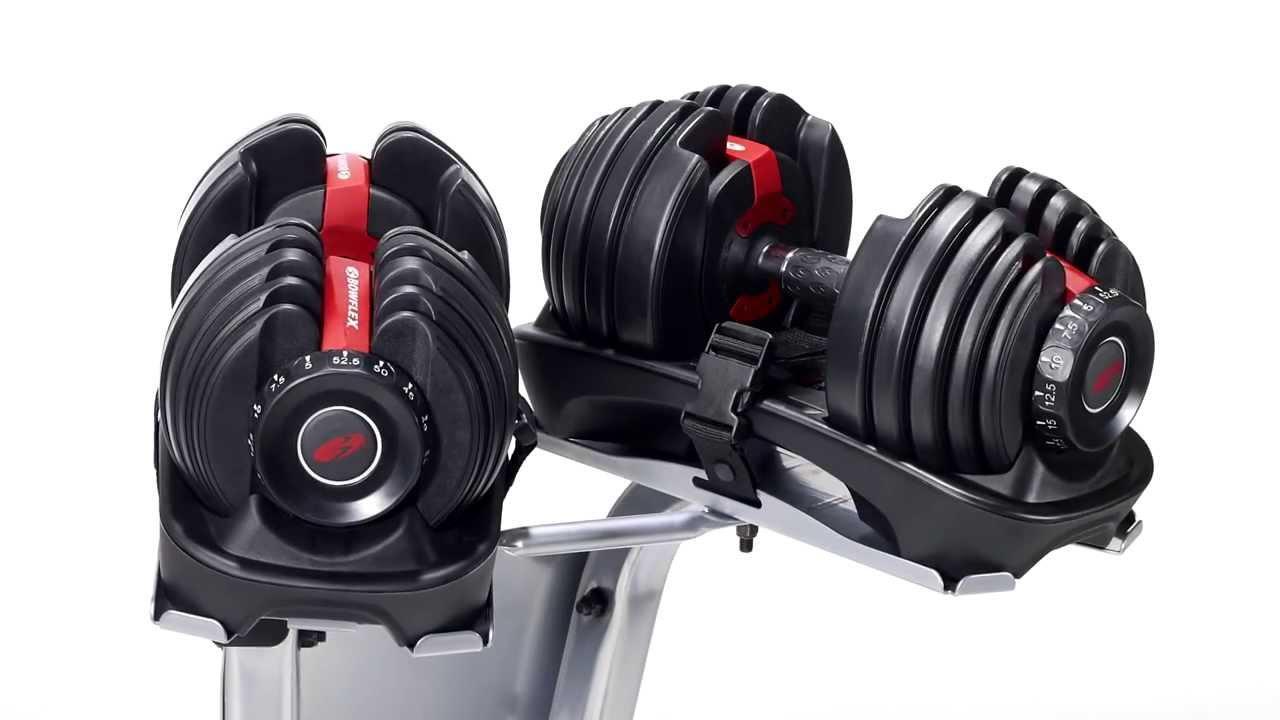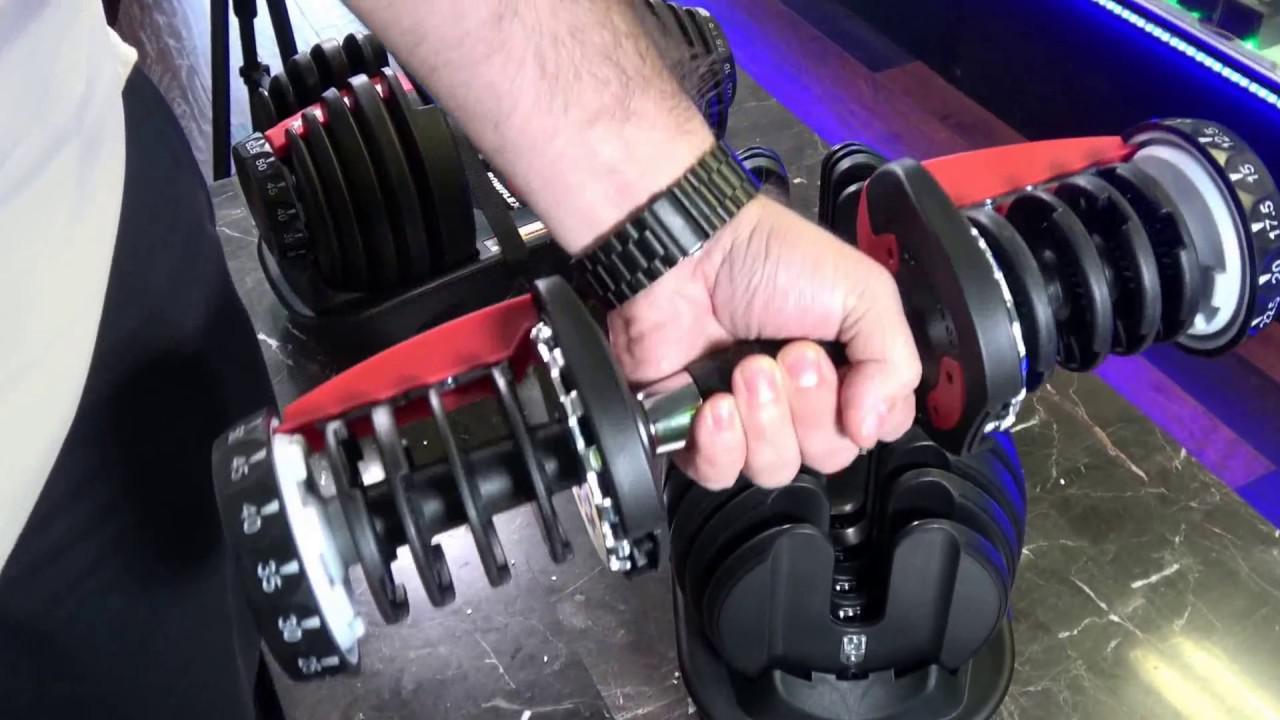The first image is the image on the left, the second image is the image on the right. Analyze the images presented: Is the assertion "There is exactly one hand visible." valid? Answer yes or no. Yes. 